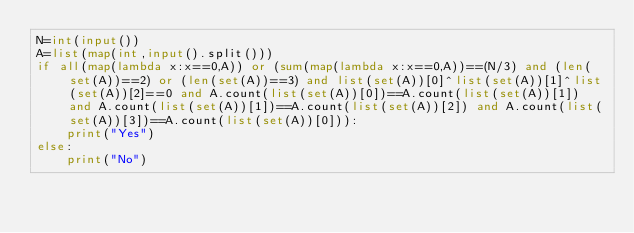Convert code to text. <code><loc_0><loc_0><loc_500><loc_500><_Python_>N=int(input())
A=list(map(int,input().split()))
if all(map(lambda x:x==0,A)) or (sum(map(lambda x:x==0,A))==(N/3) and (len(set(A))==2) or (len(set(A))==3) and list(set(A))[0]^list(set(A))[1]^list(set(A))[2]==0 and A.count(list(set(A))[0])==A.count(list(set(A))[1]) and A.count(list(set(A))[1])==A.count(list(set(A))[2]) and A.count(list(set(A))[3])==A.count(list(set(A))[0])):
    print("Yes")
else:
    print("No")</code> 